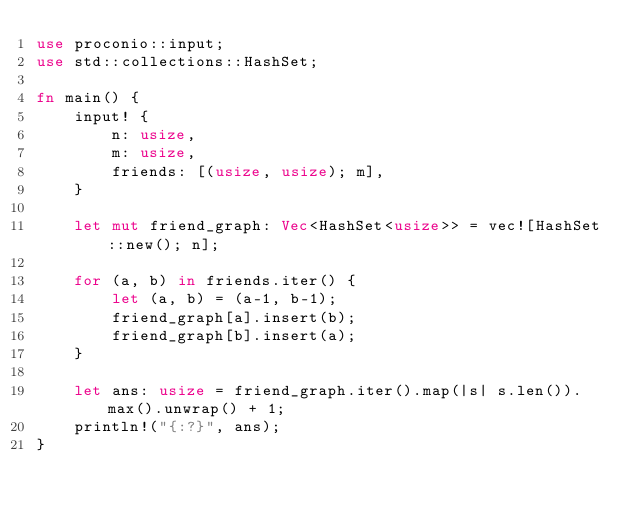Convert code to text. <code><loc_0><loc_0><loc_500><loc_500><_Rust_>use proconio::input;
use std::collections::HashSet;

fn main() {
    input! {
        n: usize,
        m: usize,
        friends: [(usize, usize); m],
    }

    let mut friend_graph: Vec<HashSet<usize>> = vec![HashSet::new(); n];

    for (a, b) in friends.iter() {
        let (a, b) = (a-1, b-1);
        friend_graph[a].insert(b);
        friend_graph[b].insert(a);
    }    

    let ans: usize = friend_graph.iter().map(|s| s.len()).max().unwrap() + 1;
    println!("{:?}", ans);
}
</code> 